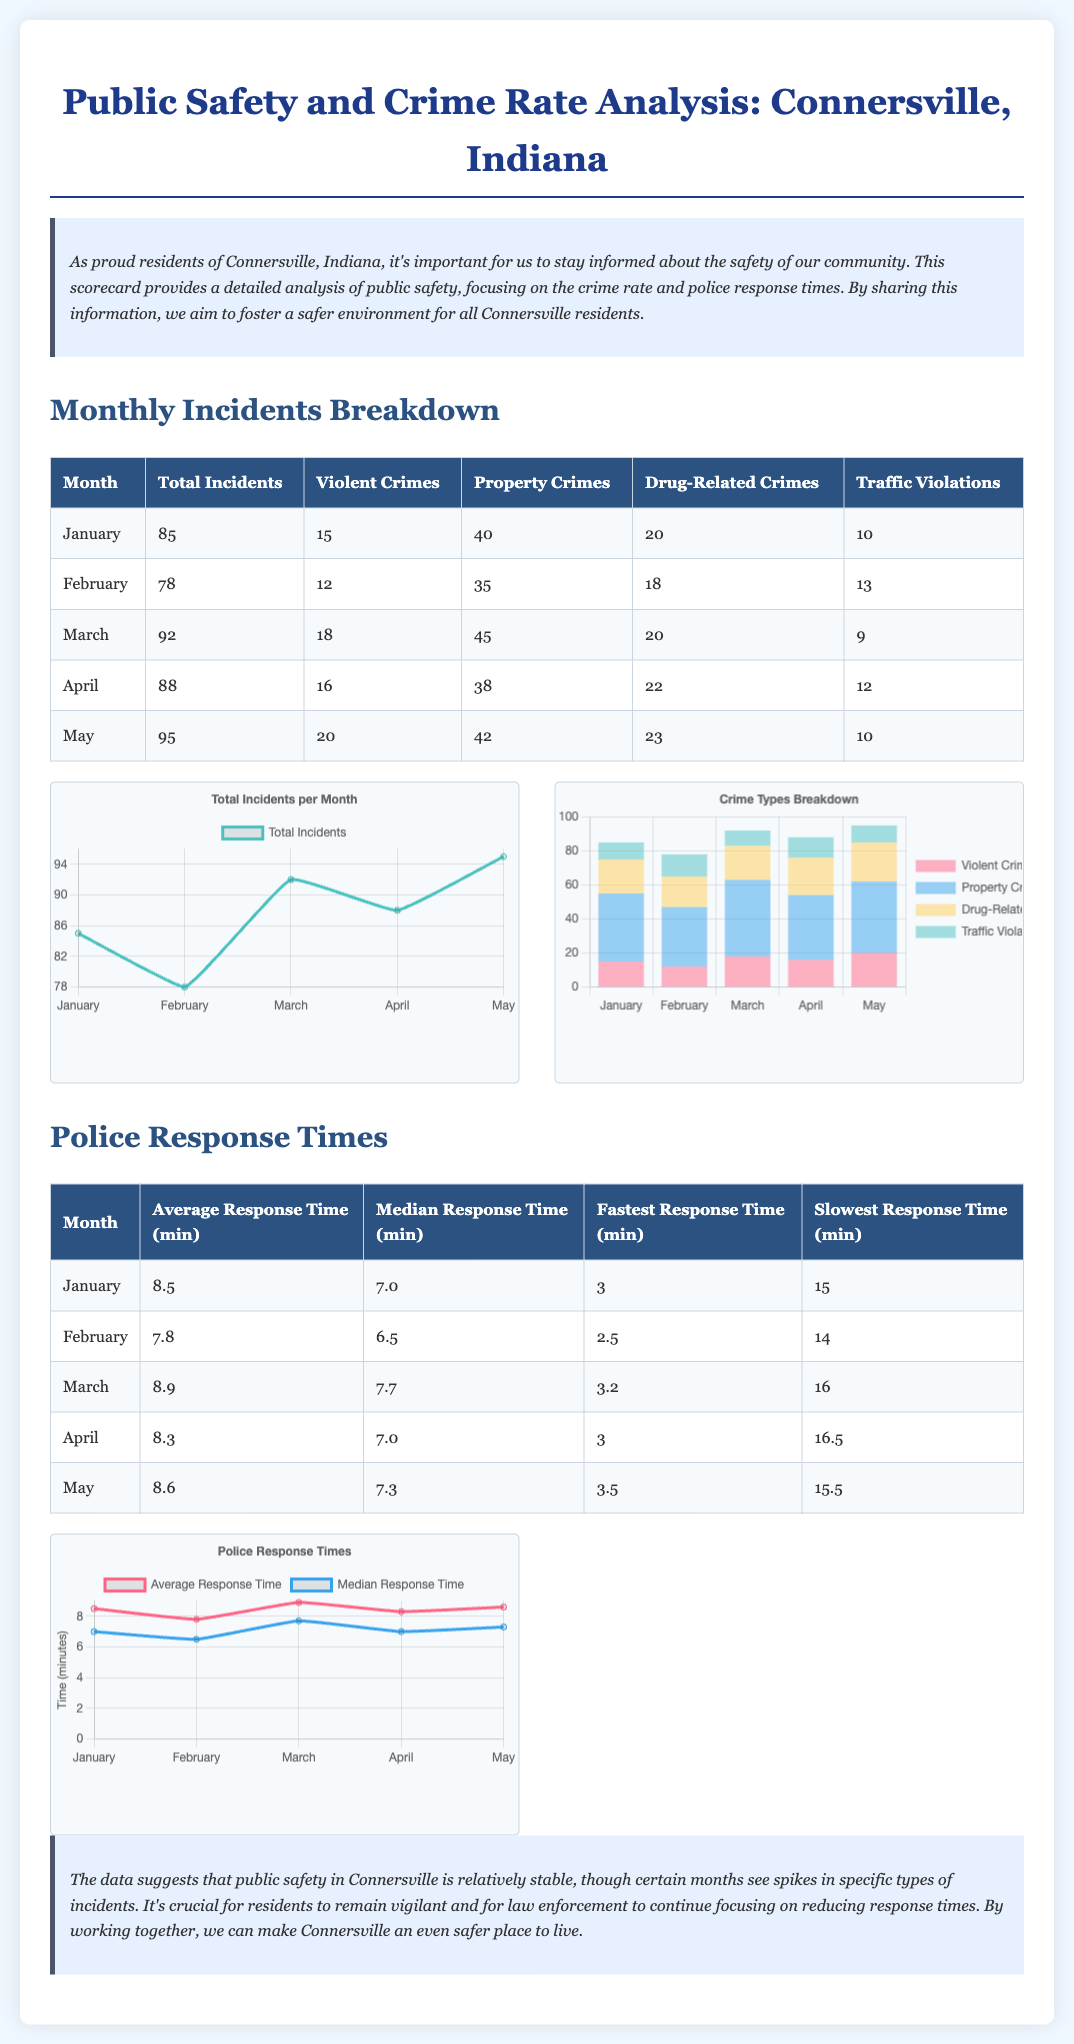What is the total number of incidents in May? The total incidents for May are specified in the monthly breakdown table, which shows 95 incidents.
Answer: 95 How many violent crimes were reported in March? The number of violent crimes for March is provided in the table, which indicates 18 violent crimes.
Answer: 18 What is the average response time in February? The average response time for February is listed in the response times table, which shows 7.8 minutes.
Answer: 7.8 Which month had the highest number of property crimes? The comparison of property crimes across the months reveals that March had the highest number at 45.
Answer: March What is the fastest response time recorded in April? The fastest response time for April is mentioned in the table, which displays a time of 3 minutes.
Answer: 3 What percentage of total incidents in January were drug-related? To find the percentage of drug-related incidents, we use the count of drug-related crimes (20) divided by total incidents (85), yielding approximately 23.5%.
Answer: 23.5% Which type of crime had the least number of incidents in May? The crime type with the least incidents in May, according to the breakdown, is traffic violations with a count of 10.
Answer: Traffic Violations What is the overall trend for total incidents from January to May? Analyzing the total incidents, the trend shows an increase from January (85) to May (95).
Answer: Increasing What is the total number of drug-related crimes reported across the five months? The total number of drug-related crimes can be calculated by adding up all values from the drug-related crimes row in the monthly breakdown table (20 + 18 + 20 + 22 + 23).
Answer: 103 